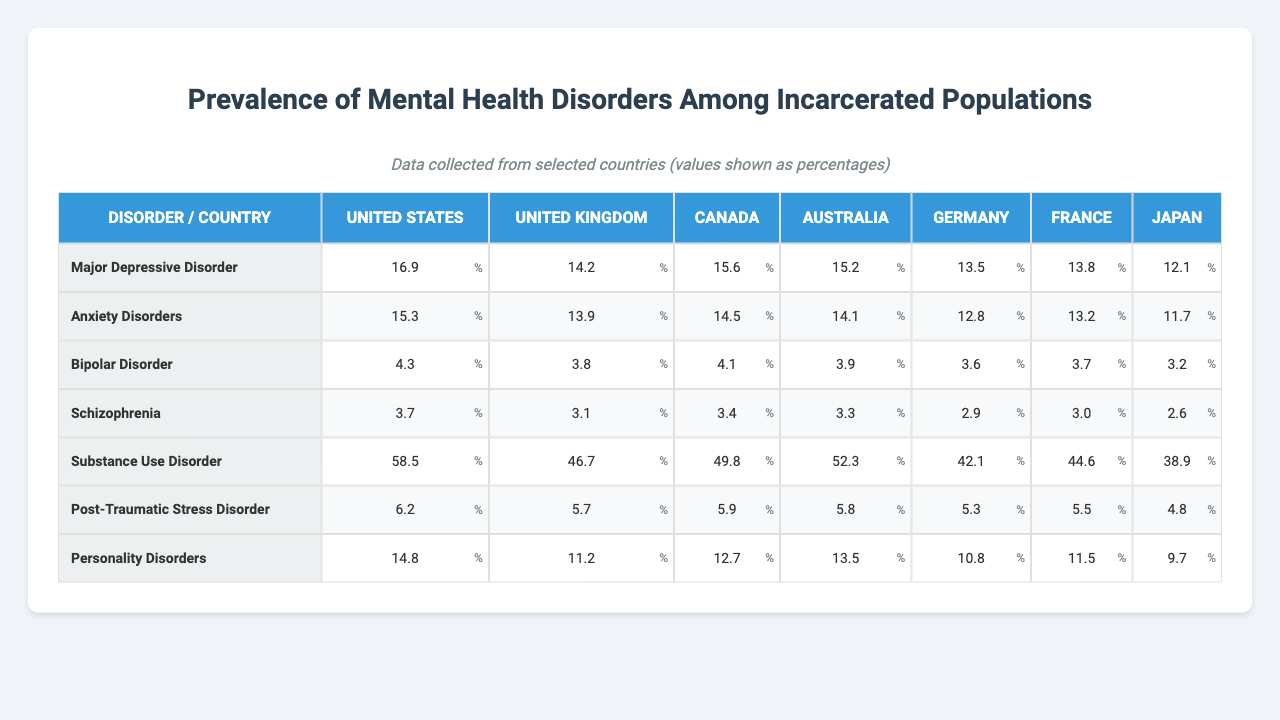What is the prevalence of Substance Use Disorder in the United States? According to the table, the prevalence of Substance Use Disorder in the United States is listed under that country and disorder, which is 58.5%.
Answer: 58.5% Which country has the highest prevalence of Major Depressive Disorder? By comparing the values for Major Depressive Disorder across all countries, the United States has the highest prevalence at 16.9%.
Answer: United States What is the difference in prevalence of Anxiety Disorders between the United States and Canada? The prevalence of Anxiety Disorders in the United States is 15.3%, and in Canada, it is 14.5%. The difference is calculated as 15.3% - 14.5% = 0.8%.
Answer: 0.8% Is the prevalence of Post-Traumatic Stress Disorder higher in Australia than in Germany? In Australia, the prevalence of Post-Traumatic Stress Disorder is 5.8%, while in Germany, it is 5.3%. Since 5.8% is greater than 5.3%, the statement is true.
Answer: Yes What is the average prevalence of Bipolar Disorder across all countries listed? To find the average prevalence, sum the values of Bipolar Disorder: (4.3 + 3.8 + 4.1 + 3.9 + 3.6 + 3.7 + 3.2) = 26.6%. There are 7 countries, so the average is 26.6% / 7 = 3.8%.
Answer: 3.8% Which disorder has the lowest reported prevalence in Japan? Reviewing the data for Japan, the lowest prevalence is for Schizophrenia at 2.6%.
Answer: Schizophrenia How does the prevalence of Anxiety Disorders in the United Kingdom compare to that in France? The prevalence of Anxiety Disorders in the United Kingdom is 13.9%, while in France, it is 13.2%. Since 13.9% is greater than 13.2%, the prevalence is higher in the United Kingdom.
Answer: Higher in the United Kingdom What is the total prevalence of all disorders in Germany? To find the total prevalence, sum all the listed values for Germany: (13.5 + 12.8 + 3.6 + 2.9 + 42.1 + 5.3 + 10.8) = 91.0%.
Answer: 91.0% Which disorder is most prevalent in the United Kingdom when compared to other countries? The highest value for any disorder in the UK is Substance Use Disorder at 46.7%, compared to the other countries listed.
Answer: Substance Use Disorder Is the prevalence of Personality Disorders the same in Canada and France? In Canada, the prevalence of Personality Disorders is 12.7%, and in France, it is 11.5%. Since 12.7% does not equal 11.5%, the statement is false.
Answer: No Which country has a prevalence of Schizophrenia that is closest to the average across all listed countries? The average for Schizophrenia can be calculated from the values: (3.7 + 3.1 + 3.4 + 3.3 + 2.9 + 3.0 + 2.6 = 20.0%)/7 = 2.86%. Japan, with a prevalence of 2.6%, is the closest to this average.
Answer: Japan 